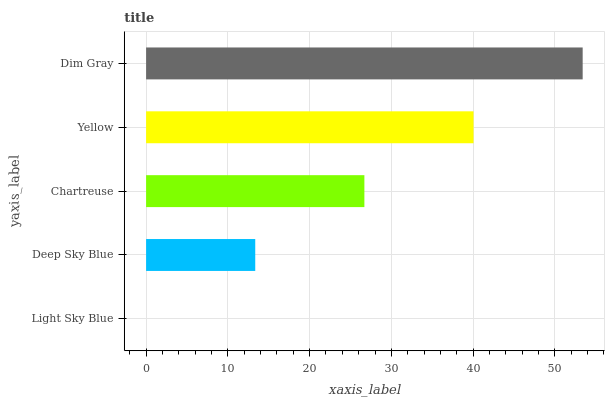Is Light Sky Blue the minimum?
Answer yes or no. Yes. Is Dim Gray the maximum?
Answer yes or no. Yes. Is Deep Sky Blue the minimum?
Answer yes or no. No. Is Deep Sky Blue the maximum?
Answer yes or no. No. Is Deep Sky Blue greater than Light Sky Blue?
Answer yes or no. Yes. Is Light Sky Blue less than Deep Sky Blue?
Answer yes or no. Yes. Is Light Sky Blue greater than Deep Sky Blue?
Answer yes or no. No. Is Deep Sky Blue less than Light Sky Blue?
Answer yes or no. No. Is Chartreuse the high median?
Answer yes or no. Yes. Is Chartreuse the low median?
Answer yes or no. Yes. Is Dim Gray the high median?
Answer yes or no. No. Is Deep Sky Blue the low median?
Answer yes or no. No. 